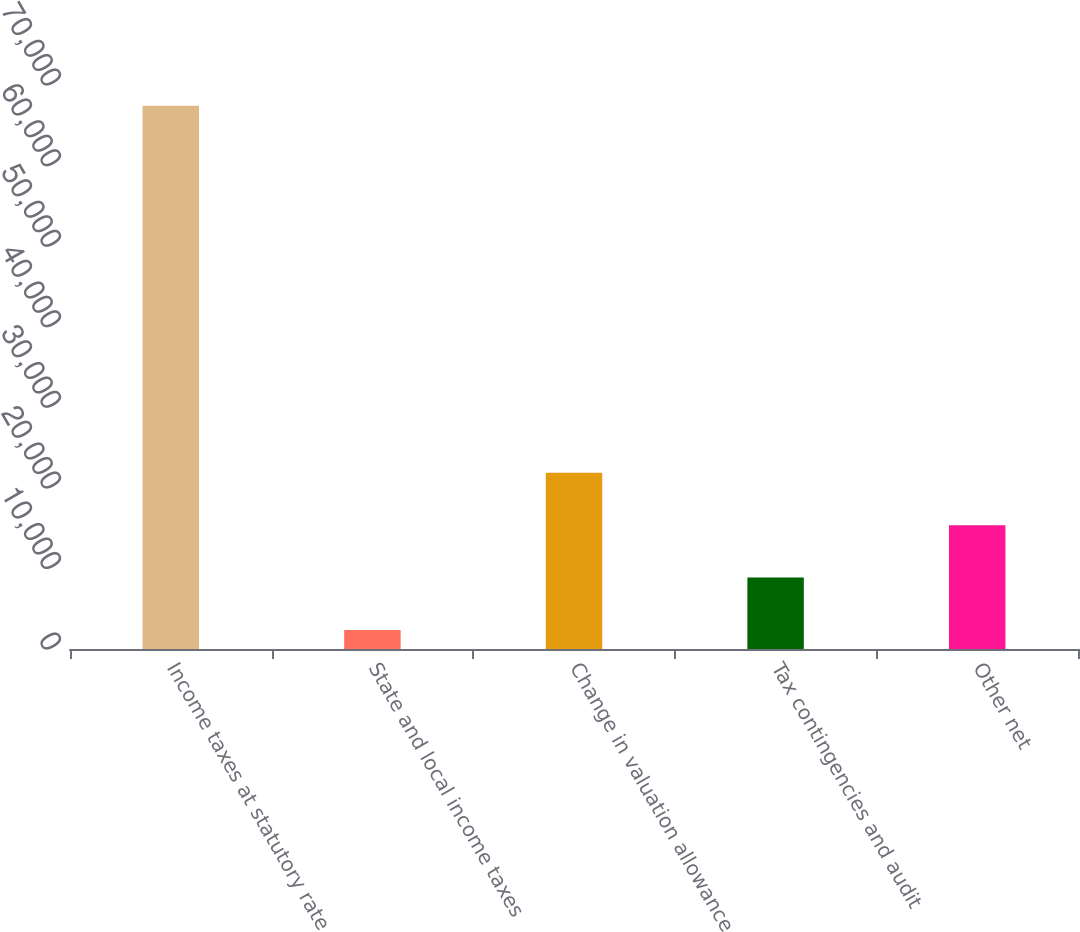Convert chart. <chart><loc_0><loc_0><loc_500><loc_500><bar_chart><fcel>Income taxes at statutory rate<fcel>State and local income taxes<fcel>Change in valuation allowance<fcel>Tax contingencies and audit<fcel>Other net<nl><fcel>67427<fcel>2358<fcel>21878.7<fcel>8864.9<fcel>15371.8<nl></chart> 